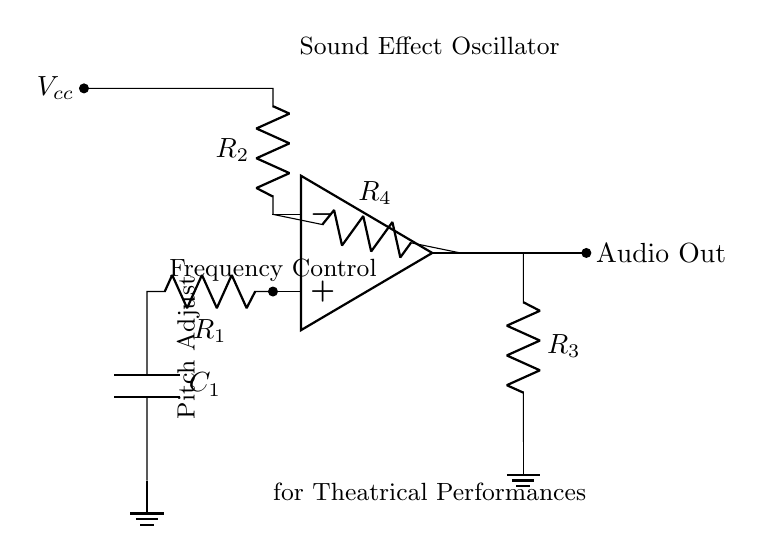What type of circuit is this? This circuit is a sound effect oscillator, designed to create audio cues. Its function is indicated by the label above it in the diagram, which states "Sound Effect Oscillator."
Answer: Sound effect oscillator What component is used for frequency control? The component responsible for frequency control is labeled as R1, which is typically a resistor that influences the timing and frequency of the signal generated by the oscillator.
Answer: R1 How many resistors are in this circuit? By inspecting the diagram, there are a total of four resistors labeled R1, R2, R3, and R4, all indicated by R symbols.
Answer: Four Where does the audio output connect? The audio output connects to a node labeled "Audio Out," which is found two units to the right of the operational amplifier output, indicating the point where the sound effect leaves the circuit.
Answer: Audio Out What is the relationship between R2 and the power supply? R2 connects directly to the power supply labeled as Vcc, derived from the positive terminal, indicating it plays a role in the circuit's biasing for the op-amp.
Answer: Biasing Which component is connected to ground? The components connected to ground are C1 and R3, as shown in the diagram, where both are drawn pointing towards a ground node. This indicates that they are part of the negative reference for the circuit.
Answer: C1 and R3 How can the pitch be adjusted in this circuit? The pitch can be adjusted through R1, as noted with the label "Pitch Adjust" above it, which suggests that changing its resistance will modify the frequency and hence the pitch of the sound generated.
Answer: R1 